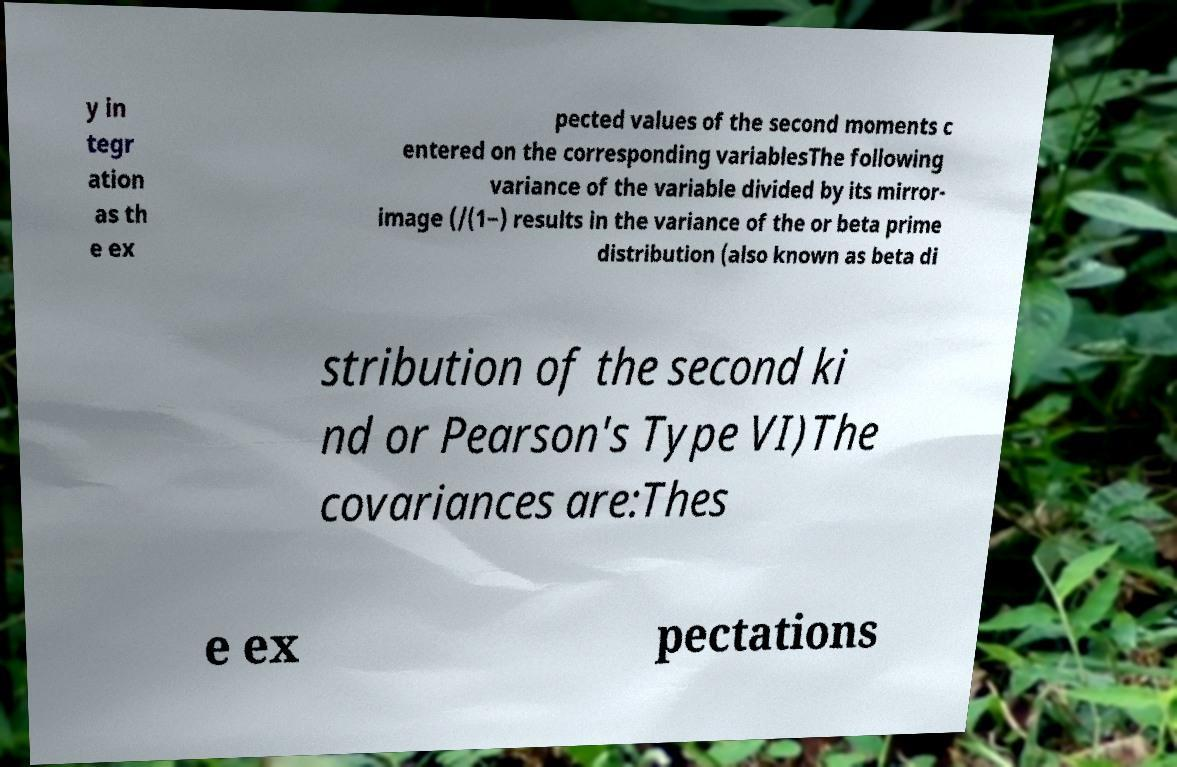Please identify and transcribe the text found in this image. y in tegr ation as th e ex pected values of the second moments c entered on the corresponding variablesThe following variance of the variable divided by its mirror- image (/(1−) results in the variance of the or beta prime distribution (also known as beta di stribution of the second ki nd or Pearson's Type VI)The covariances are:Thes e ex pectations 